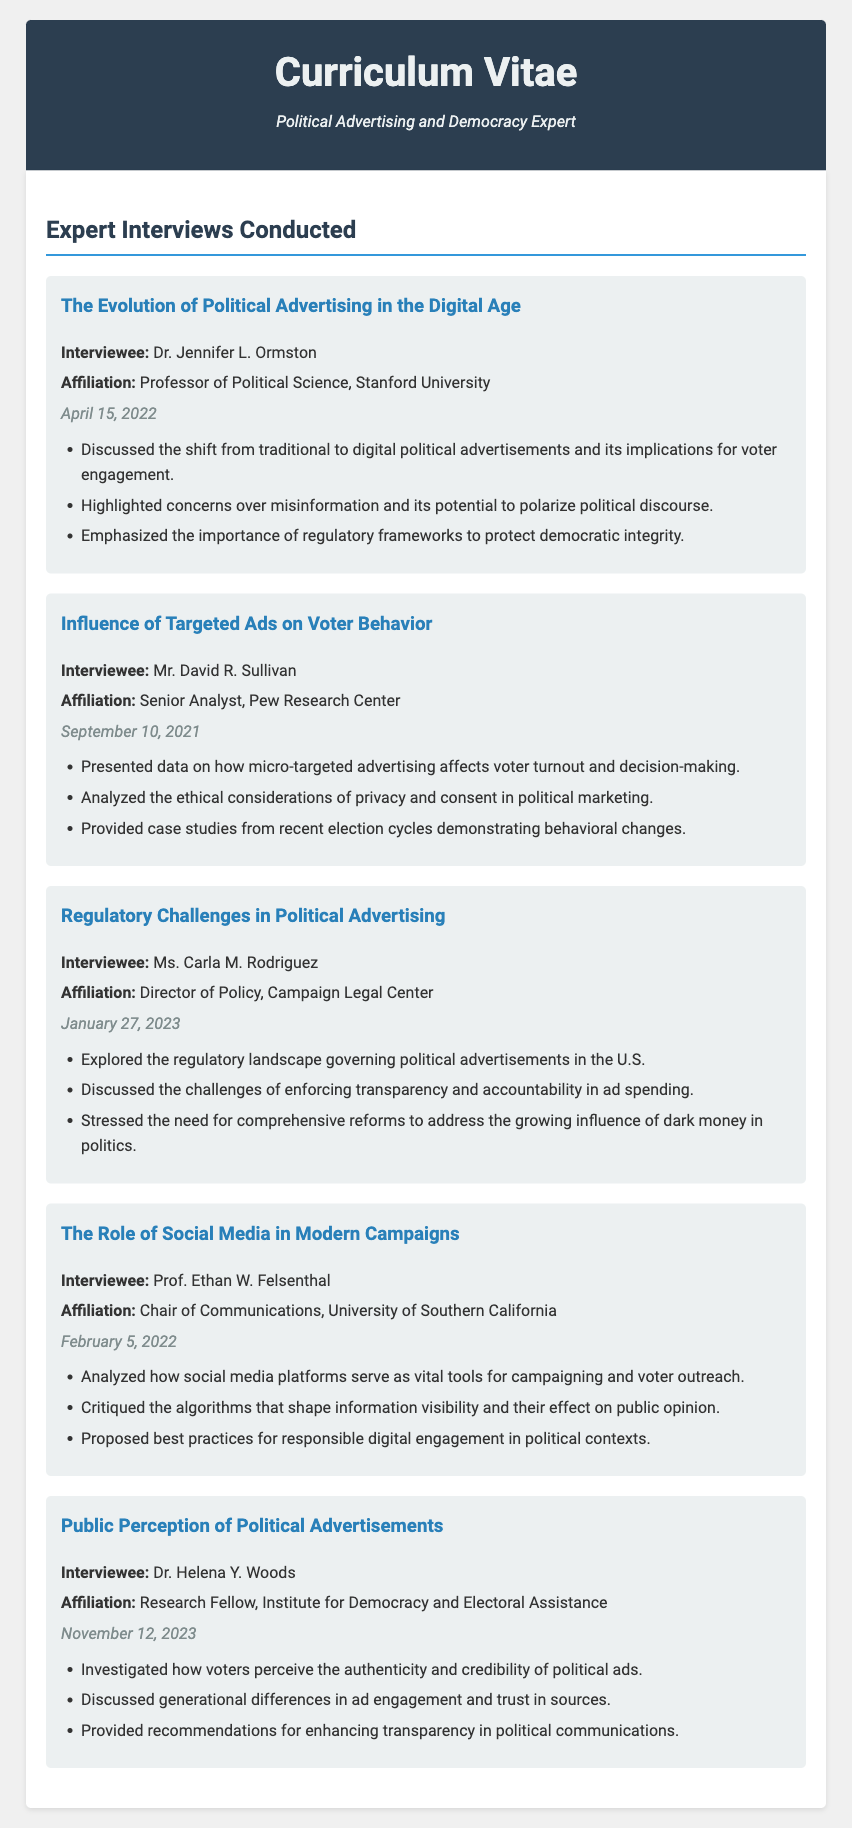What is the title of the document? The title is stated in the header of the document.
Answer: Curriculum Vitae - Political Advertising Expert Who conducted the interview about the influence of targeted ads on voter behavior? The name of the interviewee is listed under the interview section regarding targeted ads.
Answer: Mr. David R. Sullivan What is the date of the interview with Dr. Helena Y. Woods? The date of the interview is provided beneath the interviewee's name.
Answer: November 12, 2023 Which organization is Ms. Carla M. Rodriguez affiliated with? The affiliation is mentioned directly after the interviewee's name.
Answer: Campaign Legal Center What main concern did Dr. Jennifer L. Ormston highlight about digital political advertisements? This concern is indicated as one of the main discussion points in the interview.
Answer: Misinformation How many interviews are documented in the CV? The number of interviews can be counted by reviewing the individual interview sections.
Answer: Five 